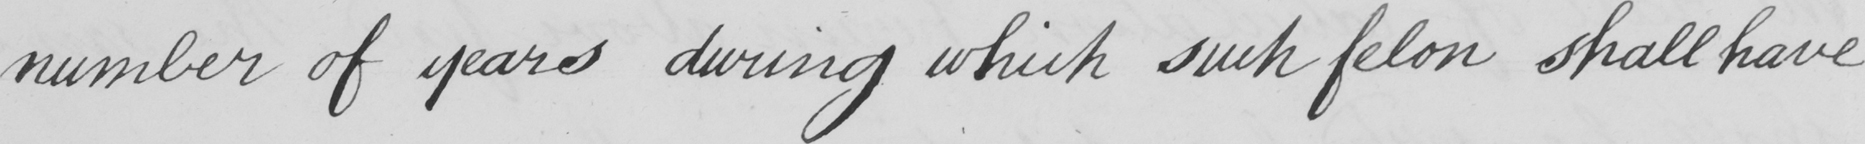What text is written in this handwritten line? number of years during which such felon shall have 